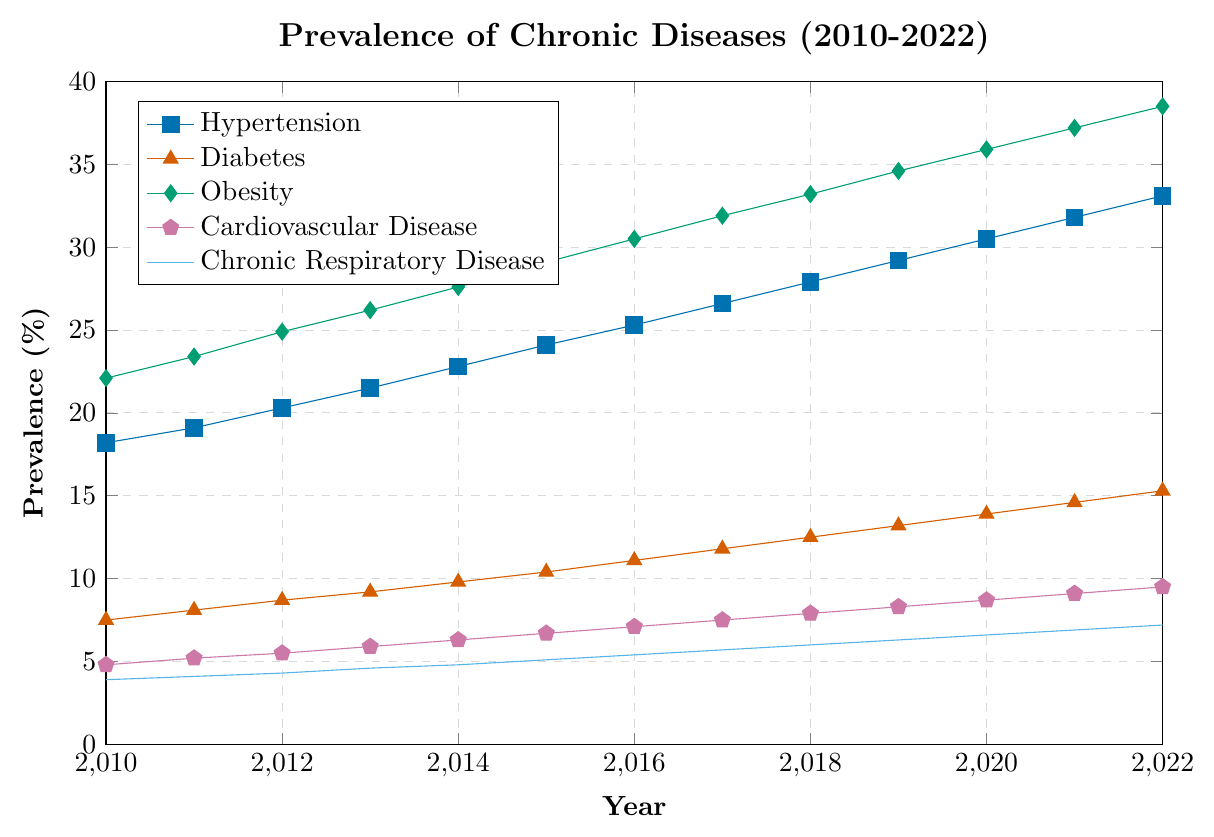Which chronic disease had the highest prevalence in 2010? Look at the starting points of the lines in 2010 and identify which line starts at the highest value. Obesity starts at 22.1% in 2010, which is the highest.
Answer: Obesity How much did the prevalence of Hypertension increase from 2010 to 2022? To find the increase, subtract the 2010 value from the 2022 value: 33.1% (2022) - 18.2% (2010) = 14.9%.
Answer: 14.9% Which chronic disease showed the most significant increase in prevalence between 2010 and 2022? Calculate the difference between 2010 and 2022 for each disease and compare. Obesity increased the most: 38.5% (2022) - 22.1% (2010) = 16.4%.
Answer: Obesity In which year did Cardiovascular Disease surpass a prevalence of 8%? Look along the Cardiovascular Disease line for the first year it exceeds 8%. In 2019, the prevalence is 8.3%.
Answer: 2019 What is the difference in prevalence between Diabetes and Chronic Respiratory Disease in 2022? Subtract the 2022 prevalence of Chronic Respiratory Disease from Diabetes: 15.3% - 7.2% = 8.1%.
Answer: 8.1% Which chronic disease had the least prevalence in 2022? Look at the end points of the lines in 2022 and identify which is the lowest. Chronic Respiratory Disease ends at 7.2% in 2022, which is the lowest.
Answer: Chronic Respiratory Disease How did the prevalence of Chronic Respiratory Disease change from 2015 to 2020? Subtract the 2015 value from the 2020 value: 6.6% (2020) - 5.1% (2015) = 1.5%.
Answer: 1.5% On average, by how much did the prevalence of Obesity increase per year between 2010 and 2022? Calculate the total increase and divide by the number of years: (38.5% - 22.1%) / (2022 - 2010) = 16.4% / 12 = 1.367%.
Answer: 1.367% Did any chronic disease show a decrease in prevalence between any two consecutive years? Examine each line closely to see if any segment slopes downward. No lines show a decrease between any two consecutive years.
Answer: No 